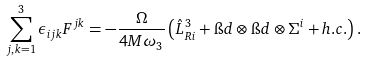<formula> <loc_0><loc_0><loc_500><loc_500>\sum _ { j , k = 1 } ^ { 3 } \epsilon _ { i j k } F ^ { j k } = - \frac { \Omega } { 4 M \omega _ { 3 } } \left ( \hat { L } _ { R i } ^ { 3 } + \i d \otimes \i d \otimes \Sigma ^ { i } + h . c . \right ) .</formula> 